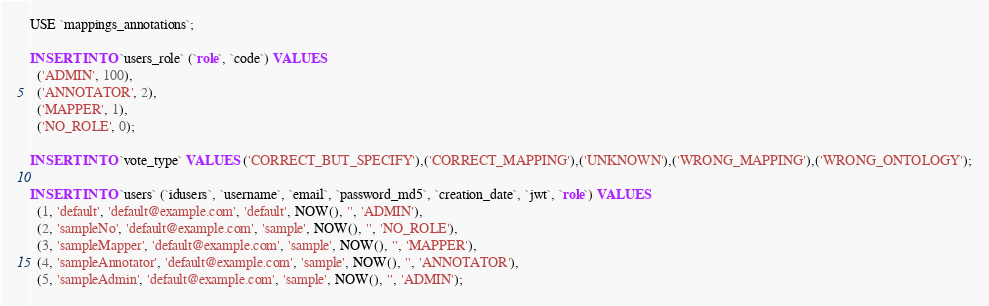<code> <loc_0><loc_0><loc_500><loc_500><_SQL_>USE `mappings_annotations`;

INSERT INTO `users_role` (`role`, `code`) VALUES
  ('ADMIN', 100),
  ('ANNOTATOR', 2),
  ('MAPPER', 1),
  ('NO_ROLE', 0);

INSERT INTO `vote_type` VALUES ('CORRECT_BUT_SPECIFY'),('CORRECT_MAPPING'),('UNKNOWN'),('WRONG_MAPPING'),('WRONG_ONTOLOGY');

INSERT INTO `users` (`idusers`, `username`, `email`, `password_md5`, `creation_date`, `jwt`, `role`) VALUES
  (1, 'default', 'default@example.com', 'default', NOW(), '', 'ADMIN'),
  (2, 'sampleNo', 'default@example.com', 'sample', NOW(), '', 'NO_ROLE'),
  (3, 'sampleMapper', 'default@example.com', 'sample', NOW(), '', 'MAPPER'),
  (4, 'sampleAnnotator', 'default@example.com', 'sample', NOW(), '', 'ANNOTATOR'),
  (5, 'sampleAdmin', 'default@example.com', 'sample', NOW(), '', 'ADMIN');

</code> 